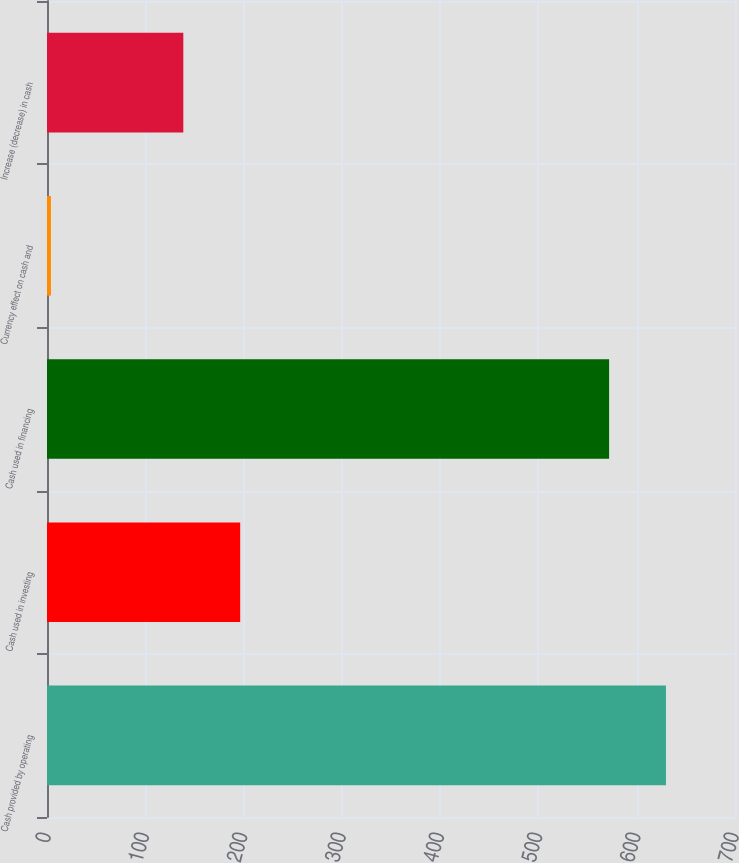<chart> <loc_0><loc_0><loc_500><loc_500><bar_chart><fcel>Cash provided by operating<fcel>Cash used in investing<fcel>Cash used in financing<fcel>Currency effect on cash and<fcel>Increase (decrease) in cash<nl><fcel>629.76<fcel>196.56<fcel>571.9<fcel>4<fcel>138.7<nl></chart> 